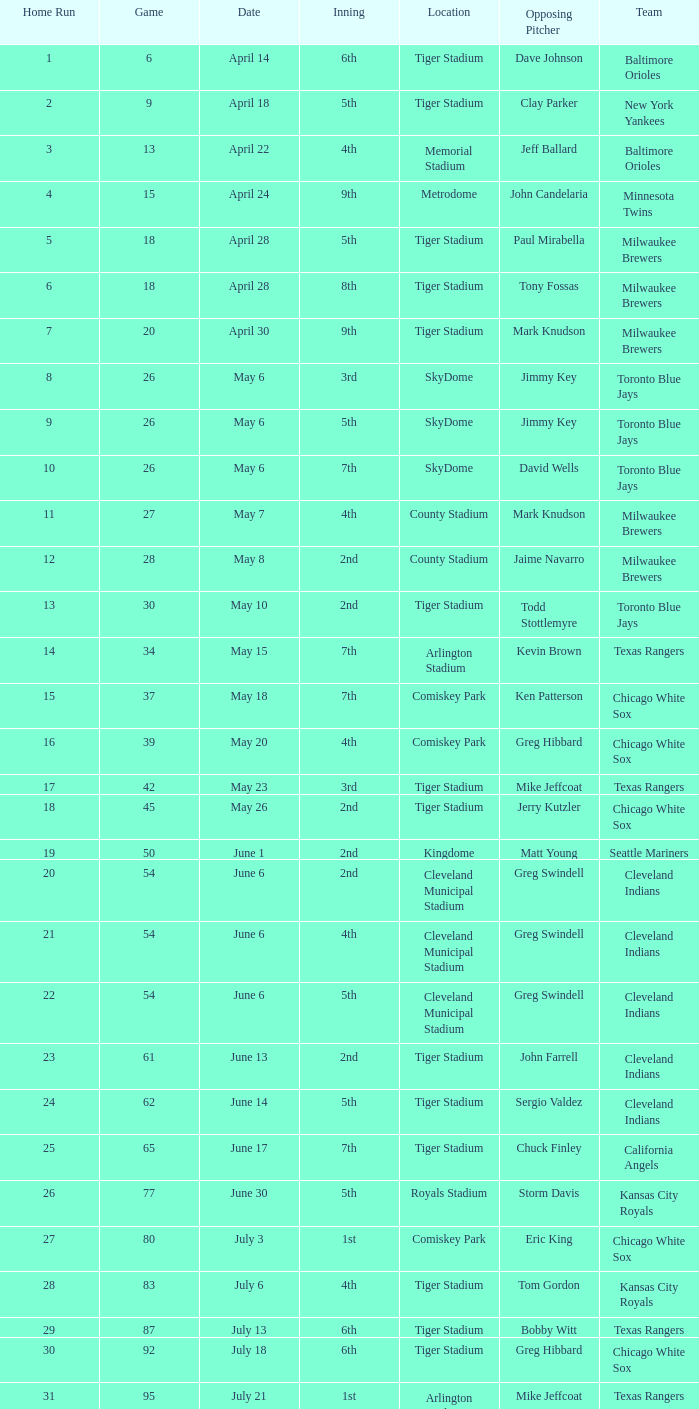On June 17 in Tiger stadium, what was the average home run? 25.0. Would you mind parsing the complete table? {'header': ['Home Run', 'Game', 'Date', 'Inning', 'Location', 'Opposing Pitcher', 'Team'], 'rows': [['1', '6', 'April 14', '6th', 'Tiger Stadium', 'Dave Johnson', 'Baltimore Orioles'], ['2', '9', 'April 18', '5th', 'Tiger Stadium', 'Clay Parker', 'New York Yankees'], ['3', '13', 'April 22', '4th', 'Memorial Stadium', 'Jeff Ballard', 'Baltimore Orioles'], ['4', '15', 'April 24', '9th', 'Metrodome', 'John Candelaria', 'Minnesota Twins'], ['5', '18', 'April 28', '5th', 'Tiger Stadium', 'Paul Mirabella', 'Milwaukee Brewers'], ['6', '18', 'April 28', '8th', 'Tiger Stadium', 'Tony Fossas', 'Milwaukee Brewers'], ['7', '20', 'April 30', '9th', 'Tiger Stadium', 'Mark Knudson', 'Milwaukee Brewers'], ['8', '26', 'May 6', '3rd', 'SkyDome', 'Jimmy Key', 'Toronto Blue Jays'], ['9', '26', 'May 6', '5th', 'SkyDome', 'Jimmy Key', 'Toronto Blue Jays'], ['10', '26', 'May 6', '7th', 'SkyDome', 'David Wells', 'Toronto Blue Jays'], ['11', '27', 'May 7', '4th', 'County Stadium', 'Mark Knudson', 'Milwaukee Brewers'], ['12', '28', 'May 8', '2nd', 'County Stadium', 'Jaime Navarro', 'Milwaukee Brewers'], ['13', '30', 'May 10', '2nd', 'Tiger Stadium', 'Todd Stottlemyre', 'Toronto Blue Jays'], ['14', '34', 'May 15', '7th', 'Arlington Stadium', 'Kevin Brown', 'Texas Rangers'], ['15', '37', 'May 18', '7th', 'Comiskey Park', 'Ken Patterson', 'Chicago White Sox'], ['16', '39', 'May 20', '4th', 'Comiskey Park', 'Greg Hibbard', 'Chicago White Sox'], ['17', '42', 'May 23', '3rd', 'Tiger Stadium', 'Mike Jeffcoat', 'Texas Rangers'], ['18', '45', 'May 26', '2nd', 'Tiger Stadium', 'Jerry Kutzler', 'Chicago White Sox'], ['19', '50', 'June 1', '2nd', 'Kingdome', 'Matt Young', 'Seattle Mariners'], ['20', '54', 'June 6', '2nd', 'Cleveland Municipal Stadium', 'Greg Swindell', 'Cleveland Indians'], ['21', '54', 'June 6', '4th', 'Cleveland Municipal Stadium', 'Greg Swindell', 'Cleveland Indians'], ['22', '54', 'June 6', '5th', 'Cleveland Municipal Stadium', 'Greg Swindell', 'Cleveland Indians'], ['23', '61', 'June 13', '2nd', 'Tiger Stadium', 'John Farrell', 'Cleveland Indians'], ['24', '62', 'June 14', '5th', 'Tiger Stadium', 'Sergio Valdez', 'Cleveland Indians'], ['25', '65', 'June 17', '7th', 'Tiger Stadium', 'Chuck Finley', 'California Angels'], ['26', '77', 'June 30', '5th', 'Royals Stadium', 'Storm Davis', 'Kansas City Royals'], ['27', '80', 'July 3', '1st', 'Comiskey Park', 'Eric King', 'Chicago White Sox'], ['28', '83', 'July 6', '4th', 'Tiger Stadium', 'Tom Gordon', 'Kansas City Royals'], ['29', '87', 'July 13', '6th', 'Tiger Stadium', 'Bobby Witt', 'Texas Rangers'], ['30', '92', 'July 18', '6th', 'Tiger Stadium', 'Greg Hibbard', 'Chicago White Sox'], ['31', '95', 'July 21', '1st', 'Arlington Stadium', 'Mike Jeffcoat', 'Texas Rangers'], ['32', '98', 'July 24', '3rd', 'Tiger Stadium', 'John Mitchell', 'Baltimore Orioles'], ['33', '104', 'July 30', '4th', 'Yankee Stadium', 'Dave LaPoint', 'New York Yankees'], ['34', '108', 'August 3', '2nd', 'Fenway Park', 'Greg Harris', 'Boston Red Sox'], ['35', '111', 'August 7', '9th', 'Skydome', 'Jimmy Key', 'Toronto Blue Jays'], ['36', '117', 'August 13', '1st', 'Cleveland Stadium', 'Jeff Shaw', 'Cleveland Indians'], ['37', '120', 'August 16', '3rd', 'Tiger Stadium', 'Ron Robinson', 'Milwaukee Brewers'], ['38', '121', 'August 17', '6th', 'Tiger Stadium', 'Tom Candiotti', 'Cleveland Indians'], ['39', '122', 'August 18', '3rd', 'Tiger Stadium', 'Efrain Valdez', 'Cleveland Indians'], ['40', '127', 'August 25', '1st', 'Tiger Stadium', 'Dave Stewart', 'Oakland Athletics'], ['41', '127', 'August 25', '4th', 'Tiger Stadium', 'Dave Stewart', 'Oakland Athletics'], ['42', '130', 'August 29', '8th', 'Kingdome', 'Matt Young', 'Seattle Mariners'], ['43', '135', 'September 3', '6th', 'Tiger Stadium', 'Jimmy Key', 'Toronto Blue Jays'], ['44', '137', 'September 5', '6th', 'Tiger Stadium', 'David Wells', 'Toronto Blue Jays'], ['45', '139', 'September 7', '6th', 'County Stadium', 'Ted Higuera', 'Milwaukee Brewers'], ['46', '145', 'September 13', '9th', 'Tiger Stadium', 'Mike Witt', 'New York Yankees'], ['47', '148', 'September 16', '5th', 'Tiger Stadium', 'Mark Leiter', 'New York Yankees'], ['48', '153', 'September 23', '2nd', 'Oakland Coliseum', 'Mike Moore', 'Oakland Athletics'], ['49', '156', 'September 27', '8th', 'Tiger Stadium', 'Dennis Lamp', 'Boston Red Sox'], ['50', '162', 'October 3', '4th', 'Yankee Stadium', 'Steve Adkins', 'New York Yankees'], ['51', '162', 'October 3', '8th', 'Yankee Stadium', 'Alan Mills', 'New York Yankees']]} 